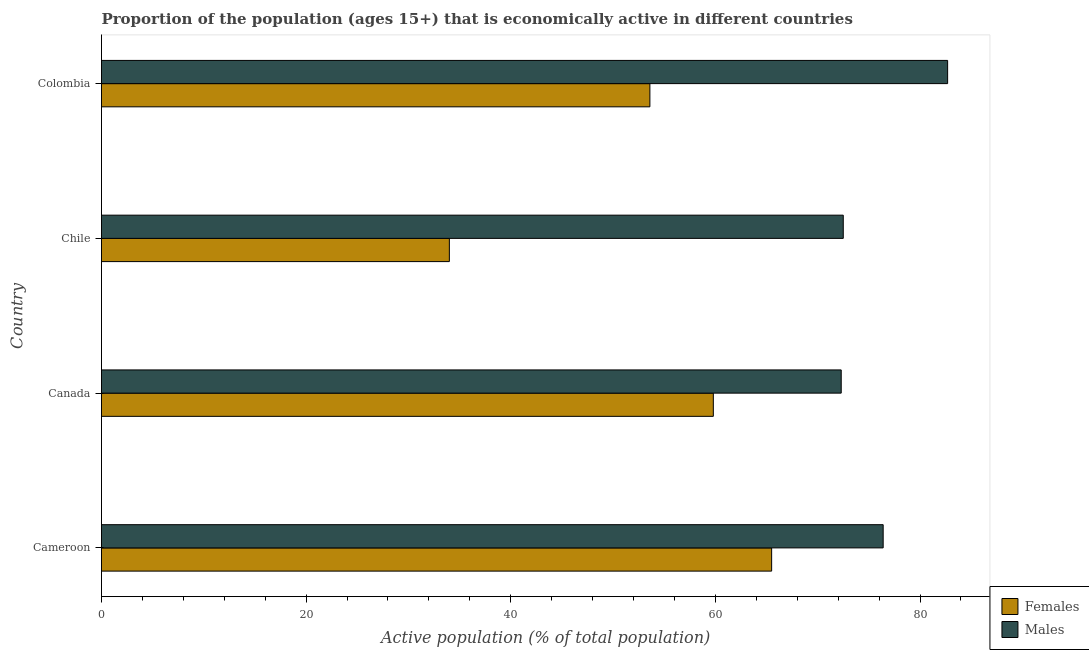How many groups of bars are there?
Make the answer very short. 4. Are the number of bars per tick equal to the number of legend labels?
Make the answer very short. Yes. Are the number of bars on each tick of the Y-axis equal?
Keep it short and to the point. Yes. How many bars are there on the 1st tick from the top?
Ensure brevity in your answer.  2. What is the label of the 4th group of bars from the top?
Make the answer very short. Cameroon. What is the percentage of economically active female population in Canada?
Give a very brief answer. 59.8. Across all countries, what is the maximum percentage of economically active male population?
Your response must be concise. 82.7. In which country was the percentage of economically active female population maximum?
Offer a terse response. Cameroon. In which country was the percentage of economically active female population minimum?
Make the answer very short. Chile. What is the total percentage of economically active male population in the graph?
Give a very brief answer. 303.9. What is the difference between the percentage of economically active female population in Cameroon and the percentage of economically active male population in Chile?
Provide a succinct answer. -7. What is the average percentage of economically active male population per country?
Your answer should be very brief. 75.97. What is the difference between the percentage of economically active male population and percentage of economically active female population in Cameroon?
Your answer should be compact. 10.9. What is the ratio of the percentage of economically active female population in Cameroon to that in Canada?
Provide a succinct answer. 1.09. What does the 2nd bar from the top in Colombia represents?
Make the answer very short. Females. What does the 1st bar from the bottom in Colombia represents?
Your answer should be very brief. Females. Are the values on the major ticks of X-axis written in scientific E-notation?
Keep it short and to the point. No. Does the graph contain grids?
Give a very brief answer. No. How are the legend labels stacked?
Your answer should be very brief. Vertical. What is the title of the graph?
Give a very brief answer. Proportion of the population (ages 15+) that is economically active in different countries. What is the label or title of the X-axis?
Ensure brevity in your answer.  Active population (% of total population). What is the label or title of the Y-axis?
Provide a succinct answer. Country. What is the Active population (% of total population) of Females in Cameroon?
Give a very brief answer. 65.5. What is the Active population (% of total population) in Males in Cameroon?
Make the answer very short. 76.4. What is the Active population (% of total population) in Females in Canada?
Your response must be concise. 59.8. What is the Active population (% of total population) in Males in Canada?
Offer a very short reply. 72.3. What is the Active population (% of total population) of Females in Chile?
Offer a terse response. 34. What is the Active population (% of total population) of Males in Chile?
Provide a succinct answer. 72.5. What is the Active population (% of total population) in Females in Colombia?
Offer a very short reply. 53.6. What is the Active population (% of total population) of Males in Colombia?
Keep it short and to the point. 82.7. Across all countries, what is the maximum Active population (% of total population) in Females?
Offer a very short reply. 65.5. Across all countries, what is the maximum Active population (% of total population) in Males?
Your answer should be very brief. 82.7. Across all countries, what is the minimum Active population (% of total population) of Males?
Provide a short and direct response. 72.3. What is the total Active population (% of total population) in Females in the graph?
Offer a terse response. 212.9. What is the total Active population (% of total population) of Males in the graph?
Make the answer very short. 303.9. What is the difference between the Active population (% of total population) in Females in Cameroon and that in Canada?
Keep it short and to the point. 5.7. What is the difference between the Active population (% of total population) in Males in Cameroon and that in Canada?
Your answer should be compact. 4.1. What is the difference between the Active population (% of total population) in Females in Cameroon and that in Chile?
Offer a terse response. 31.5. What is the difference between the Active population (% of total population) in Males in Cameroon and that in Chile?
Your response must be concise. 3.9. What is the difference between the Active population (% of total population) of Females in Cameroon and that in Colombia?
Your answer should be compact. 11.9. What is the difference between the Active population (% of total population) in Females in Canada and that in Chile?
Provide a succinct answer. 25.8. What is the difference between the Active population (% of total population) in Females in Canada and that in Colombia?
Keep it short and to the point. 6.2. What is the difference between the Active population (% of total population) of Males in Canada and that in Colombia?
Make the answer very short. -10.4. What is the difference between the Active population (% of total population) in Females in Chile and that in Colombia?
Your answer should be very brief. -19.6. What is the difference between the Active population (% of total population) in Males in Chile and that in Colombia?
Provide a short and direct response. -10.2. What is the difference between the Active population (% of total population) in Females in Cameroon and the Active population (% of total population) in Males in Colombia?
Give a very brief answer. -17.2. What is the difference between the Active population (% of total population) of Females in Canada and the Active population (% of total population) of Males in Chile?
Give a very brief answer. -12.7. What is the difference between the Active population (% of total population) in Females in Canada and the Active population (% of total population) in Males in Colombia?
Offer a very short reply. -22.9. What is the difference between the Active population (% of total population) in Females in Chile and the Active population (% of total population) in Males in Colombia?
Offer a very short reply. -48.7. What is the average Active population (% of total population) of Females per country?
Your answer should be very brief. 53.23. What is the average Active population (% of total population) of Males per country?
Offer a very short reply. 75.97. What is the difference between the Active population (% of total population) in Females and Active population (% of total population) in Males in Canada?
Ensure brevity in your answer.  -12.5. What is the difference between the Active population (% of total population) in Females and Active population (% of total population) in Males in Chile?
Your response must be concise. -38.5. What is the difference between the Active population (% of total population) of Females and Active population (% of total population) of Males in Colombia?
Your response must be concise. -29.1. What is the ratio of the Active population (% of total population) in Females in Cameroon to that in Canada?
Your answer should be very brief. 1.1. What is the ratio of the Active population (% of total population) of Males in Cameroon to that in Canada?
Give a very brief answer. 1.06. What is the ratio of the Active population (% of total population) in Females in Cameroon to that in Chile?
Your answer should be compact. 1.93. What is the ratio of the Active population (% of total population) of Males in Cameroon to that in Chile?
Your response must be concise. 1.05. What is the ratio of the Active population (% of total population) in Females in Cameroon to that in Colombia?
Provide a succinct answer. 1.22. What is the ratio of the Active population (% of total population) in Males in Cameroon to that in Colombia?
Provide a short and direct response. 0.92. What is the ratio of the Active population (% of total population) of Females in Canada to that in Chile?
Your response must be concise. 1.76. What is the ratio of the Active population (% of total population) in Males in Canada to that in Chile?
Give a very brief answer. 1. What is the ratio of the Active population (% of total population) in Females in Canada to that in Colombia?
Offer a very short reply. 1.12. What is the ratio of the Active population (% of total population) of Males in Canada to that in Colombia?
Keep it short and to the point. 0.87. What is the ratio of the Active population (% of total population) in Females in Chile to that in Colombia?
Your answer should be very brief. 0.63. What is the ratio of the Active population (% of total population) of Males in Chile to that in Colombia?
Ensure brevity in your answer.  0.88. What is the difference between the highest and the second highest Active population (% of total population) of Females?
Keep it short and to the point. 5.7. What is the difference between the highest and the second highest Active population (% of total population) of Males?
Offer a very short reply. 6.3. What is the difference between the highest and the lowest Active population (% of total population) in Females?
Give a very brief answer. 31.5. 